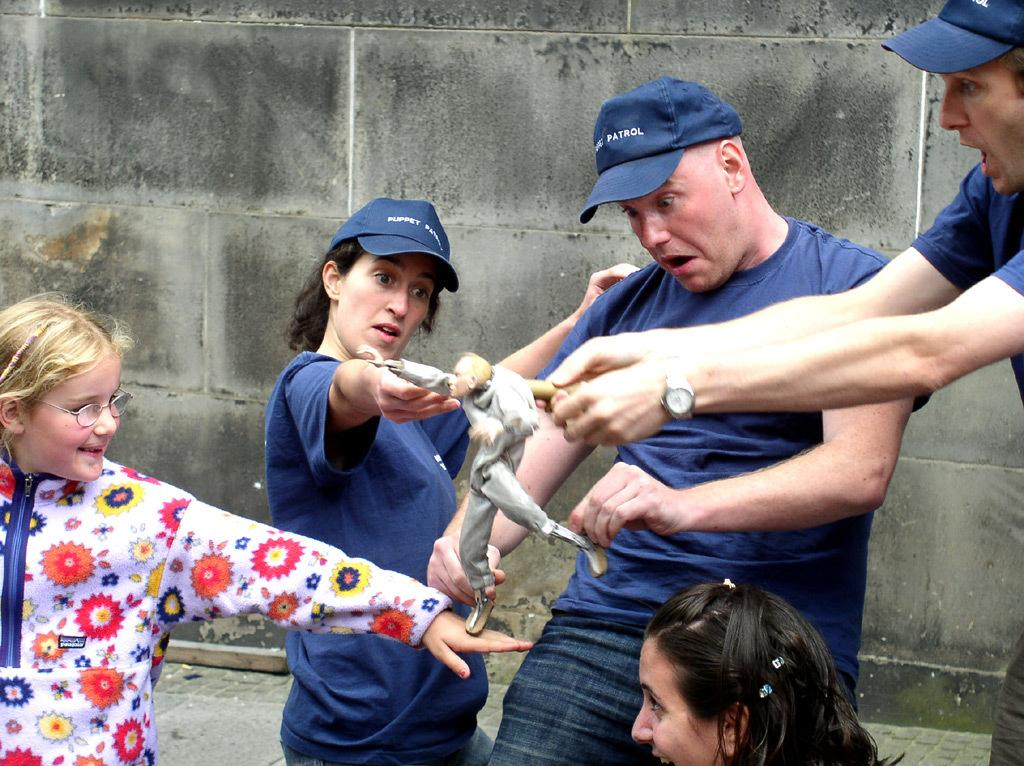How many people are present in the image? There are five persons in the image. What are the persons holding in the image? The persons are holding a toy. What can be seen in the background of the image? There is a wall in the background of the image. What type of hose is being used by the persons in the image? There is no hose present in the image; the persons are holding a toy. 